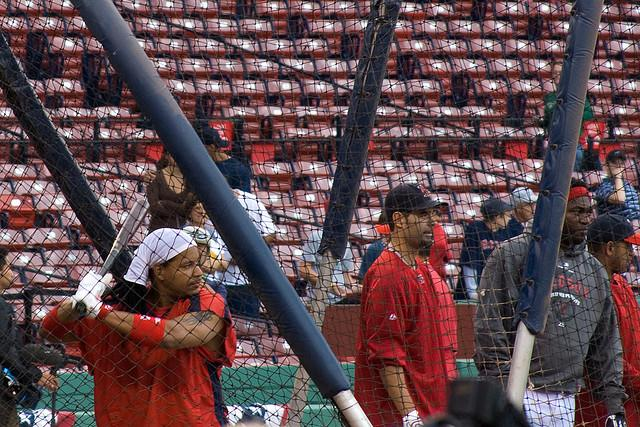Which base ball sport equipment is made up with maple wood? bat 